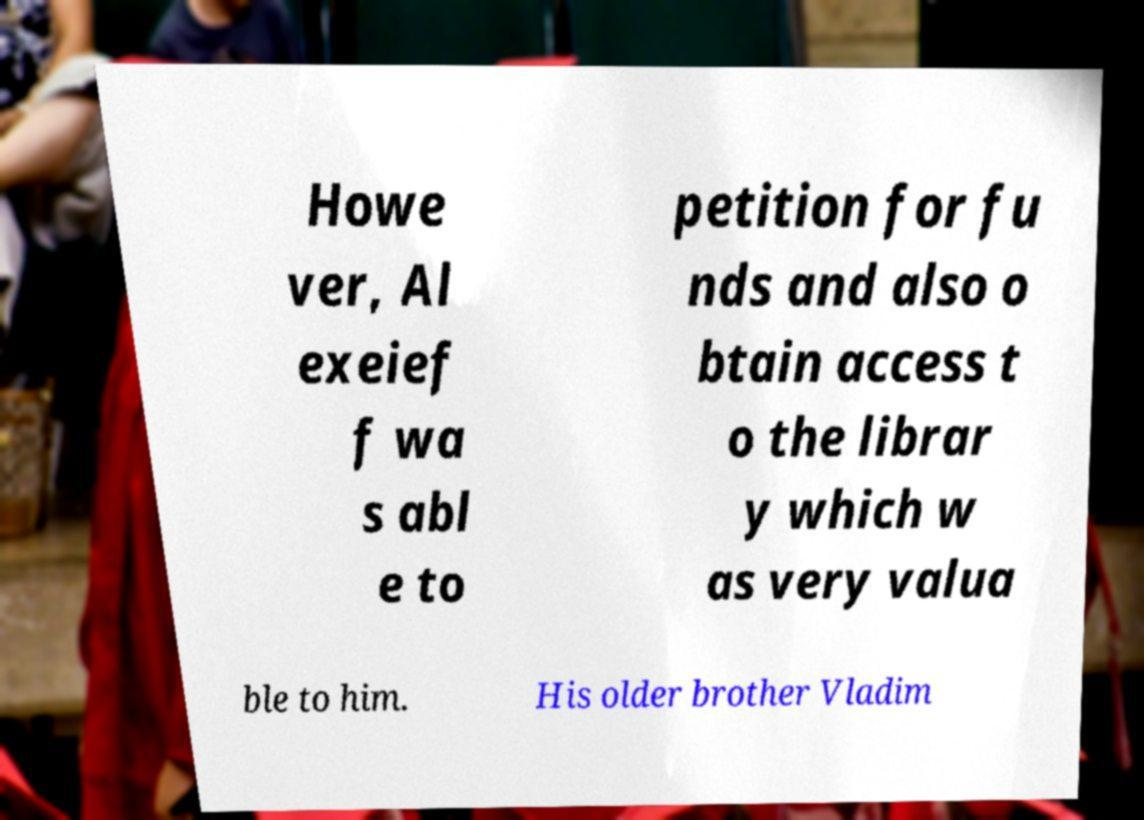There's text embedded in this image that I need extracted. Can you transcribe it verbatim? Howe ver, Al exeief f wa s abl e to petition for fu nds and also o btain access t o the librar y which w as very valua ble to him. His older brother Vladim 